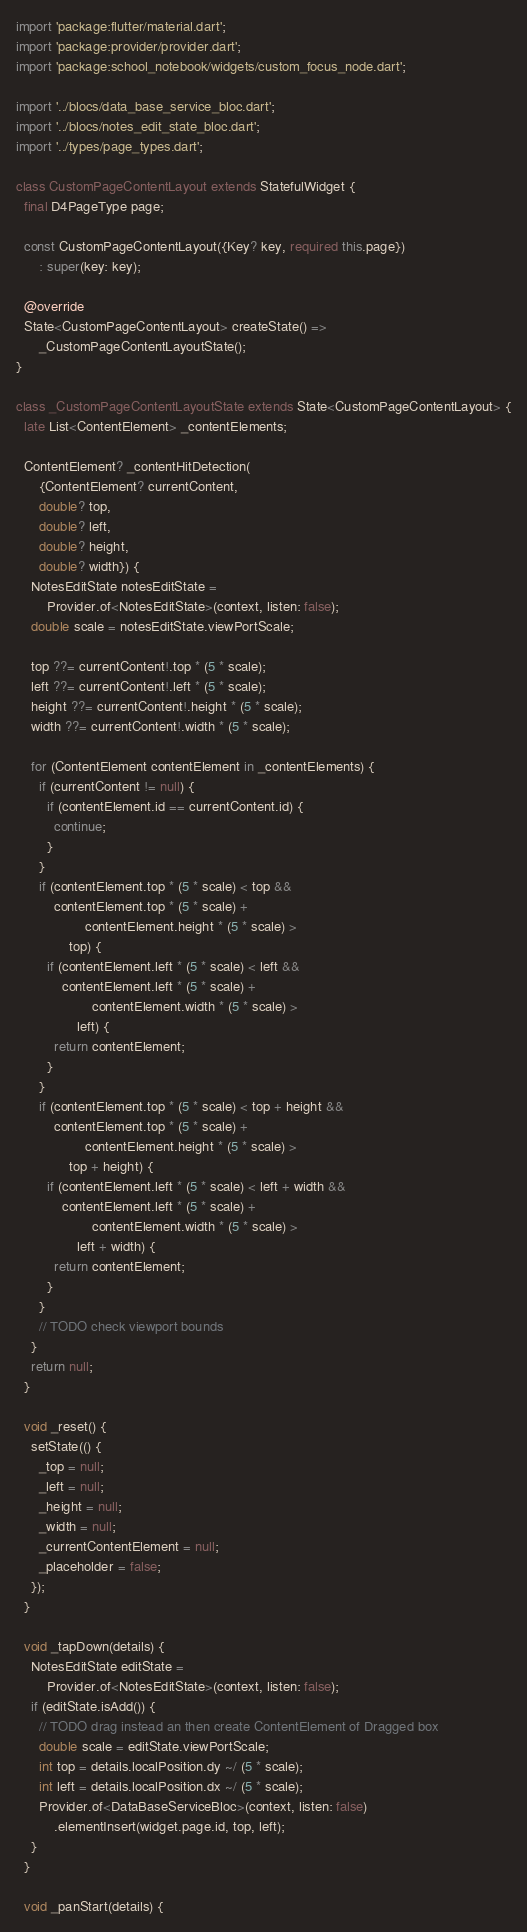<code> <loc_0><loc_0><loc_500><loc_500><_Dart_>import 'package:flutter/material.dart';
import 'package:provider/provider.dart';
import 'package:school_notebook/widgets/custom_focus_node.dart';

import '../blocs/data_base_service_bloc.dart';
import '../blocs/notes_edit_state_bloc.dart';
import '../types/page_types.dart';

class CustomPageContentLayout extends StatefulWidget {
  final D4PageType page;

  const CustomPageContentLayout({Key? key, required this.page})
      : super(key: key);

  @override
  State<CustomPageContentLayout> createState() =>
      _CustomPageContentLayoutState();
}

class _CustomPageContentLayoutState extends State<CustomPageContentLayout> {
  late List<ContentElement> _contentElements;

  ContentElement? _contentHitDetection(
      {ContentElement? currentContent,
      double? top,
      double? left,
      double? height,
      double? width}) {
    NotesEditState notesEditState =
        Provider.of<NotesEditState>(context, listen: false);
    double scale = notesEditState.viewPortScale;

    top ??= currentContent!.top * (5 * scale);
    left ??= currentContent!.left * (5 * scale);
    height ??= currentContent!.height * (5 * scale);
    width ??= currentContent!.width * (5 * scale);

    for (ContentElement contentElement in _contentElements) {
      if (currentContent != null) {
        if (contentElement.id == currentContent.id) {
          continue;
        }
      }
      if (contentElement.top * (5 * scale) < top &&
          contentElement.top * (5 * scale) +
                  contentElement.height * (5 * scale) >
              top) {
        if (contentElement.left * (5 * scale) < left &&
            contentElement.left * (5 * scale) +
                    contentElement.width * (5 * scale) >
                left) {
          return contentElement;
        }
      }
      if (contentElement.top * (5 * scale) < top + height &&
          contentElement.top * (5 * scale) +
                  contentElement.height * (5 * scale) >
              top + height) {
        if (contentElement.left * (5 * scale) < left + width &&
            contentElement.left * (5 * scale) +
                    contentElement.width * (5 * scale) >
                left + width) {
          return contentElement;
        }
      }
      // TODO check viewport bounds
    }
    return null;
  }

  void _reset() {
    setState(() {
      _top = null;
      _left = null;
      _height = null;
      _width = null;
      _currentContentElement = null;
      _placeholder = false;
    });
  }

  void _tapDown(details) {
    NotesEditState editState =
        Provider.of<NotesEditState>(context, listen: false);
    if (editState.isAdd()) {
      // TODO drag instead an then create ContentElement of Dragged box
      double scale = editState.viewPortScale;
      int top = details.localPosition.dy ~/ (5 * scale);
      int left = details.localPosition.dx ~/ (5 * scale);
      Provider.of<DataBaseServiceBloc>(context, listen: false)
          .elementInsert(widget.page.id, top, left);
    }
  }

  void _panStart(details) {</code> 